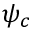Convert formula to latex. <formula><loc_0><loc_0><loc_500><loc_500>\psi _ { c }</formula> 